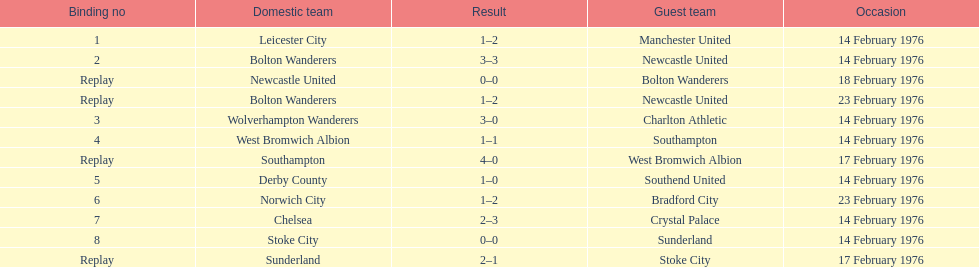Who was the home team in the game on the top of the table? Leicester City. 